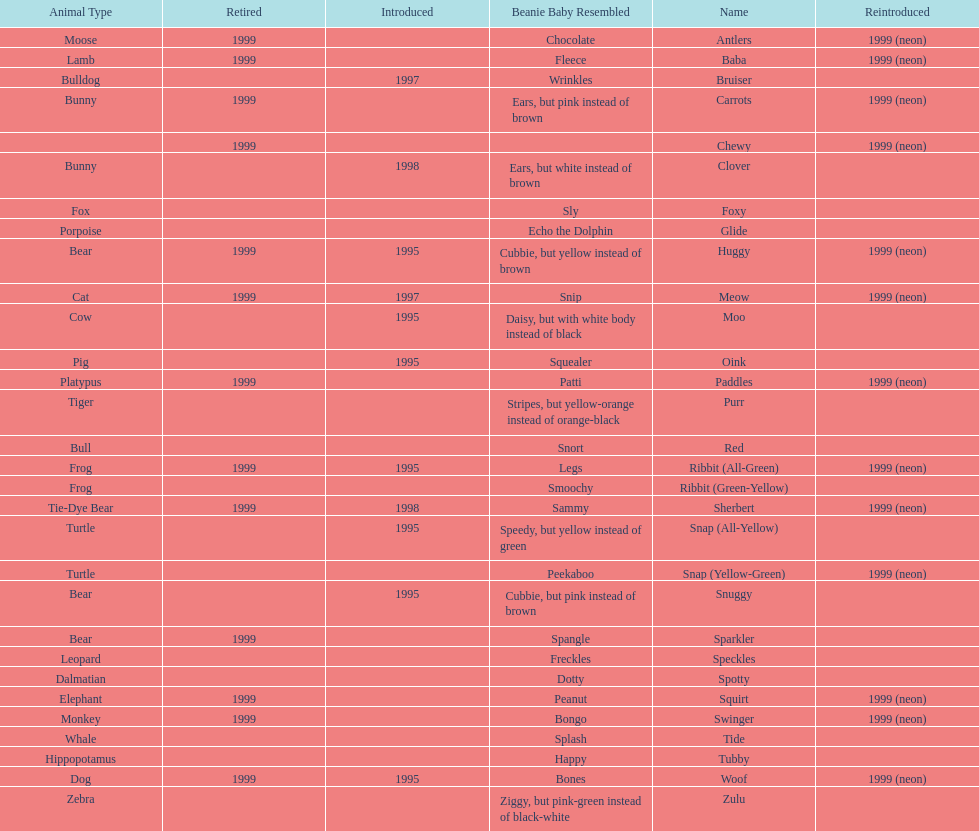Which animal type has the most pillow pals? Bear. 